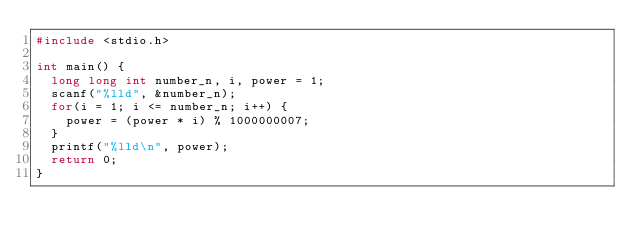<code> <loc_0><loc_0><loc_500><loc_500><_C_>#include <stdio.h>

int main() {
  long long int number_n, i, power = 1;
  scanf("%lld", &number_n);
  for(i = 1; i <= number_n; i++) {
    power = (power * i) % 1000000007;
  }
  printf("%lld\n", power);
  return 0;
}
</code> 